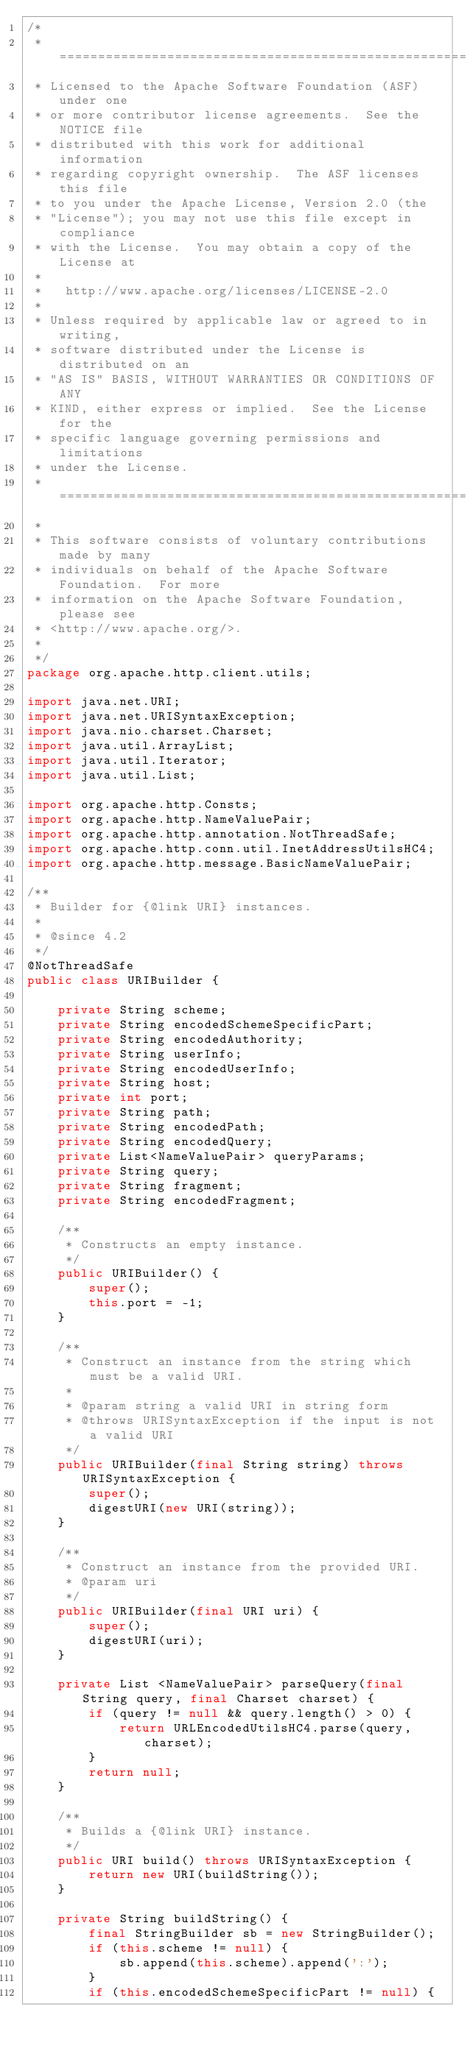<code> <loc_0><loc_0><loc_500><loc_500><_Java_>/*
 * ====================================================================
 * Licensed to the Apache Software Foundation (ASF) under one
 * or more contributor license agreements.  See the NOTICE file
 * distributed with this work for additional information
 * regarding copyright ownership.  The ASF licenses this file
 * to you under the Apache License, Version 2.0 (the
 * "License"); you may not use this file except in compliance
 * with the License.  You may obtain a copy of the License at
 *
 *   http://www.apache.org/licenses/LICENSE-2.0
 *
 * Unless required by applicable law or agreed to in writing,
 * software distributed under the License is distributed on an
 * "AS IS" BASIS, WITHOUT WARRANTIES OR CONDITIONS OF ANY
 * KIND, either express or implied.  See the License for the
 * specific language governing permissions and limitations
 * under the License.
 * ====================================================================
 *
 * This software consists of voluntary contributions made by many
 * individuals on behalf of the Apache Software Foundation.  For more
 * information on the Apache Software Foundation, please see
 * <http://www.apache.org/>.
 *
 */
package org.apache.http.client.utils;

import java.net.URI;
import java.net.URISyntaxException;
import java.nio.charset.Charset;
import java.util.ArrayList;
import java.util.Iterator;
import java.util.List;

import org.apache.http.Consts;
import org.apache.http.NameValuePair;
import org.apache.http.annotation.NotThreadSafe;
import org.apache.http.conn.util.InetAddressUtilsHC4;
import org.apache.http.message.BasicNameValuePair;

/**
 * Builder for {@link URI} instances.
 *
 * @since 4.2
 */
@NotThreadSafe
public class URIBuilder {

    private String scheme;
    private String encodedSchemeSpecificPart;
    private String encodedAuthority;
    private String userInfo;
    private String encodedUserInfo;
    private String host;
    private int port;
    private String path;
    private String encodedPath;
    private String encodedQuery;
    private List<NameValuePair> queryParams;
    private String query;
    private String fragment;
    private String encodedFragment;

    /**
     * Constructs an empty instance.
     */
    public URIBuilder() {
        super();
        this.port = -1;
    }

    /**
     * Construct an instance from the string which must be a valid URI.
     *
     * @param string a valid URI in string form
     * @throws URISyntaxException if the input is not a valid URI
     */
    public URIBuilder(final String string) throws URISyntaxException {
        super();
        digestURI(new URI(string));
    }

    /**
     * Construct an instance from the provided URI.
     * @param uri
     */
    public URIBuilder(final URI uri) {
        super();
        digestURI(uri);
    }

    private List <NameValuePair> parseQuery(final String query, final Charset charset) {
        if (query != null && query.length() > 0) {
            return URLEncodedUtilsHC4.parse(query, charset);
        }
        return null;
    }

    /**
     * Builds a {@link URI} instance.
     */
    public URI build() throws URISyntaxException {
        return new URI(buildString());
    }

    private String buildString() {
        final StringBuilder sb = new StringBuilder();
        if (this.scheme != null) {
            sb.append(this.scheme).append(':');
        }
        if (this.encodedSchemeSpecificPart != null) {</code> 